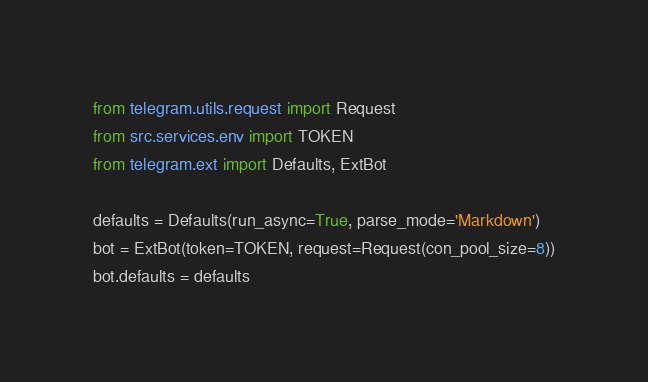Convert code to text. <code><loc_0><loc_0><loc_500><loc_500><_Python_>from telegram.utils.request import Request
from src.services.env import TOKEN
from telegram.ext import Defaults, ExtBot

defaults = Defaults(run_async=True, parse_mode='Markdown')
bot = ExtBot(token=TOKEN, request=Request(con_pool_size=8))
bot.defaults = defaults
</code> 